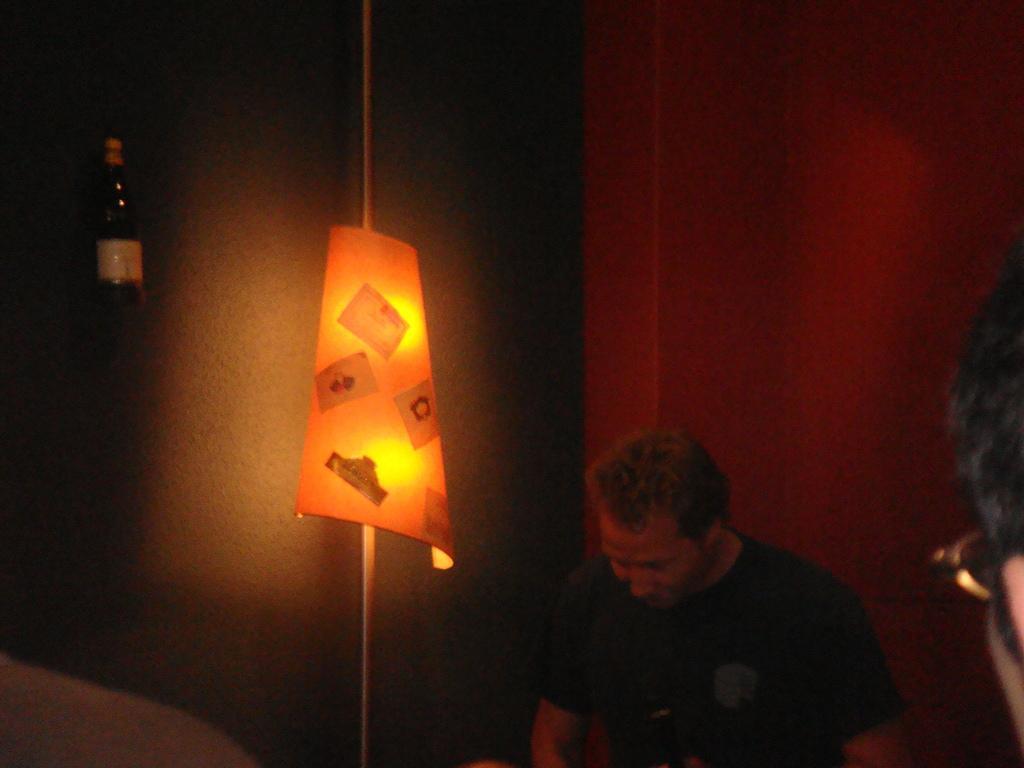Describe this image in one or two sentences. On the bottom right, there are two people, in the middle there is a light, at the top there is a bottle, in the background there is a wall. 